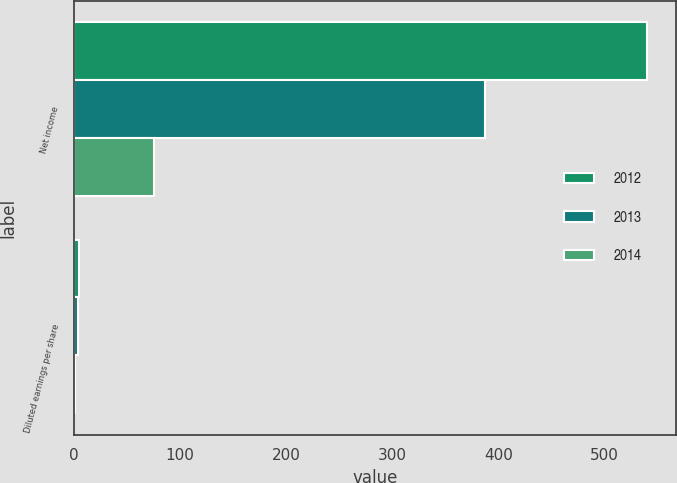Convert chart to OTSL. <chart><loc_0><loc_0><loc_500><loc_500><stacked_bar_chart><ecel><fcel>Net income<fcel>Diluted earnings per share<nl><fcel>2012<fcel>540<fcel>5.15<nl><fcel>2013<fcel>387<fcel>3.64<nl><fcel>2014<fcel>75<fcel>0.79<nl></chart> 